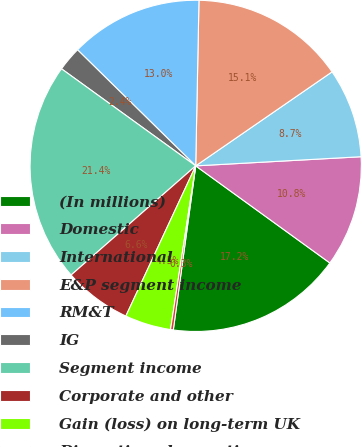Convert chart. <chart><loc_0><loc_0><loc_500><loc_500><pie_chart><fcel>(In millions)<fcel>Domestic<fcel>International<fcel>E&P segment income<fcel>RM&T<fcel>IG<fcel>Segment income<fcel>Corporate and other<fcel>Gain (loss) on long-term UK<fcel>Discontinued operations<nl><fcel>17.19%<fcel>10.85%<fcel>8.73%<fcel>15.08%<fcel>12.96%<fcel>2.39%<fcel>21.42%<fcel>6.62%<fcel>4.5%<fcel>0.27%<nl></chart> 